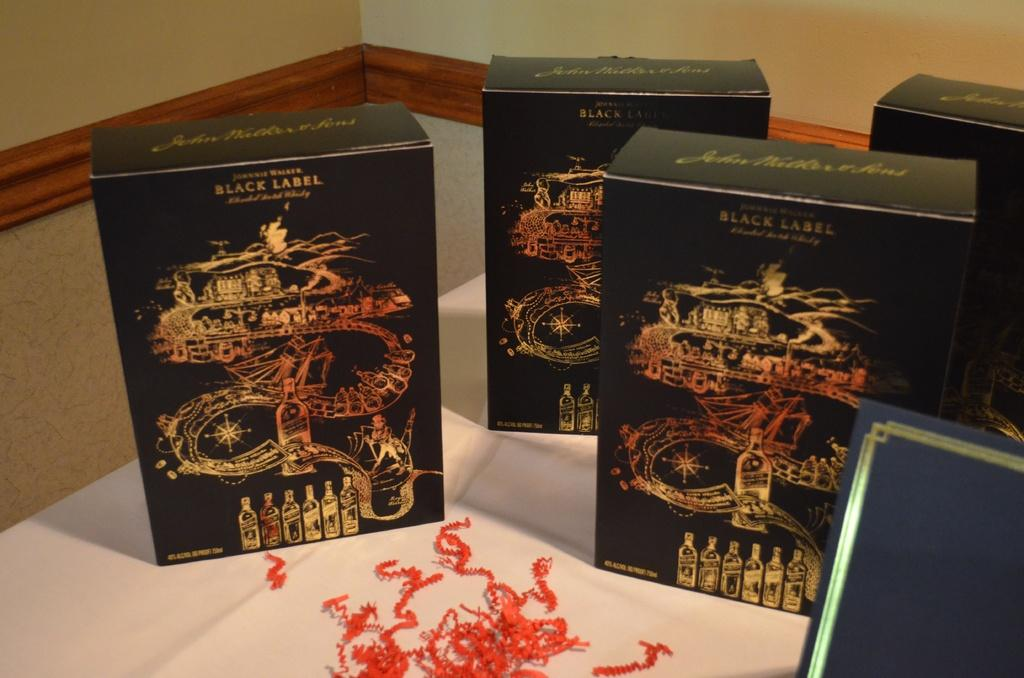<image>
Render a clear and concise summary of the photo. Elaborately decorated boxes are classified as Black Label versions of the brand. 